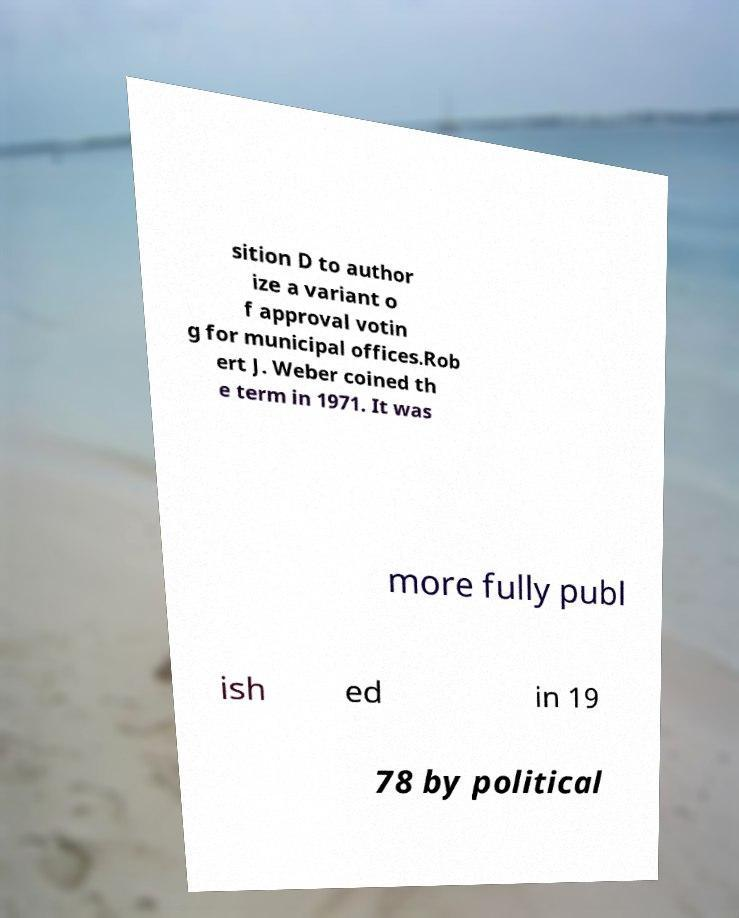Please read and relay the text visible in this image. What does it say? sition D to author ize a variant o f approval votin g for municipal offices.Rob ert J. Weber coined th e term in 1971. It was more fully publ ish ed in 19 78 by political 